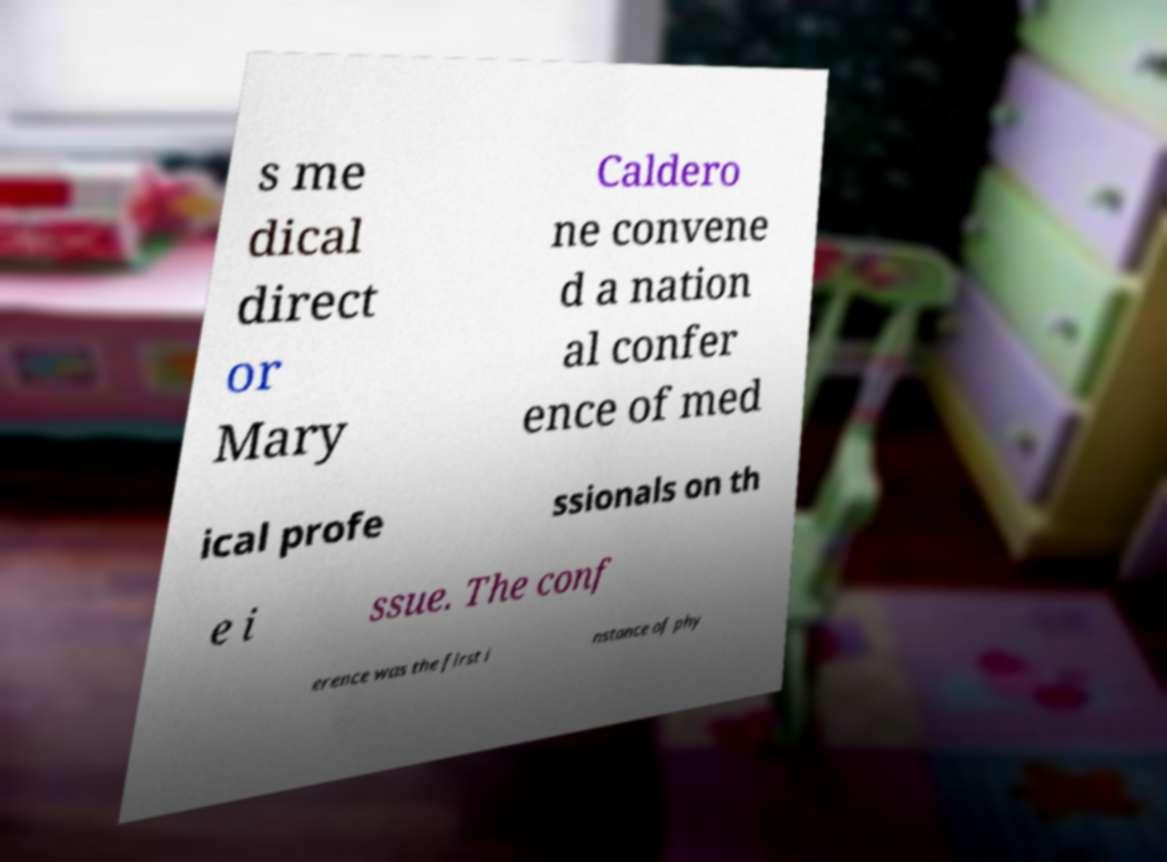Could you assist in decoding the text presented in this image and type it out clearly? s me dical direct or Mary Caldero ne convene d a nation al confer ence of med ical profe ssionals on th e i ssue. The conf erence was the first i nstance of phy 